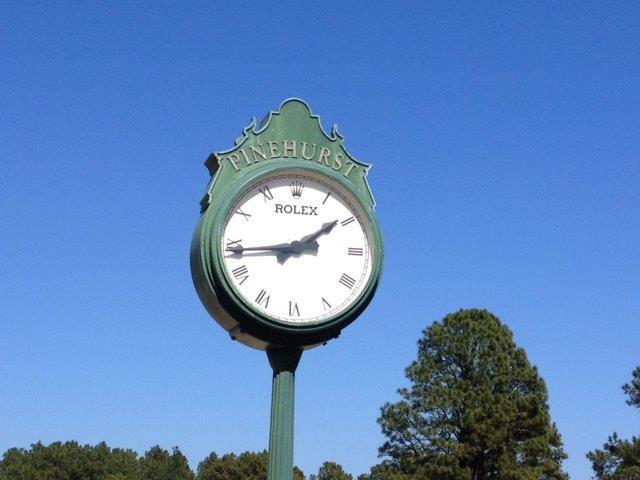What brand of clock is this?
Short answer required. Rolex. What time is the clock showing?
Short answer required. 1:45. Does the clock read 8 am?
Keep it brief. No. What kind of clock is this?
Give a very brief answer. Rolex. What word is at the top of the clock?
Short answer required. Pinehurst. 